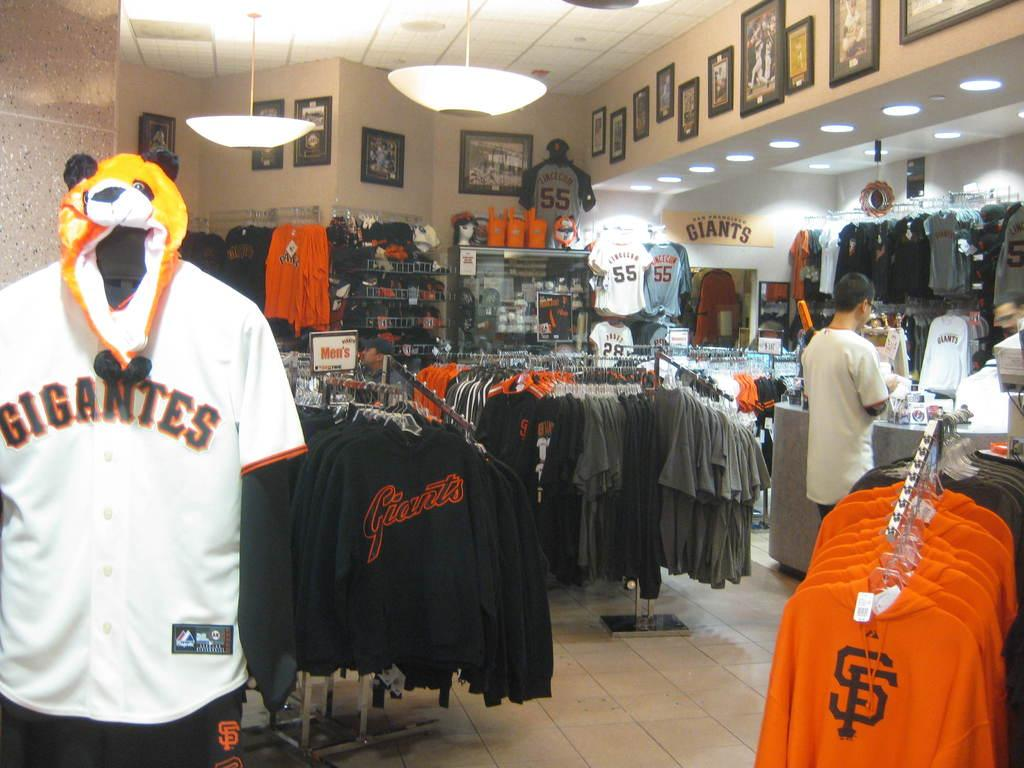<image>
Create a compact narrative representing the image presented. A number of Giants merchandise is for sale in a store. 